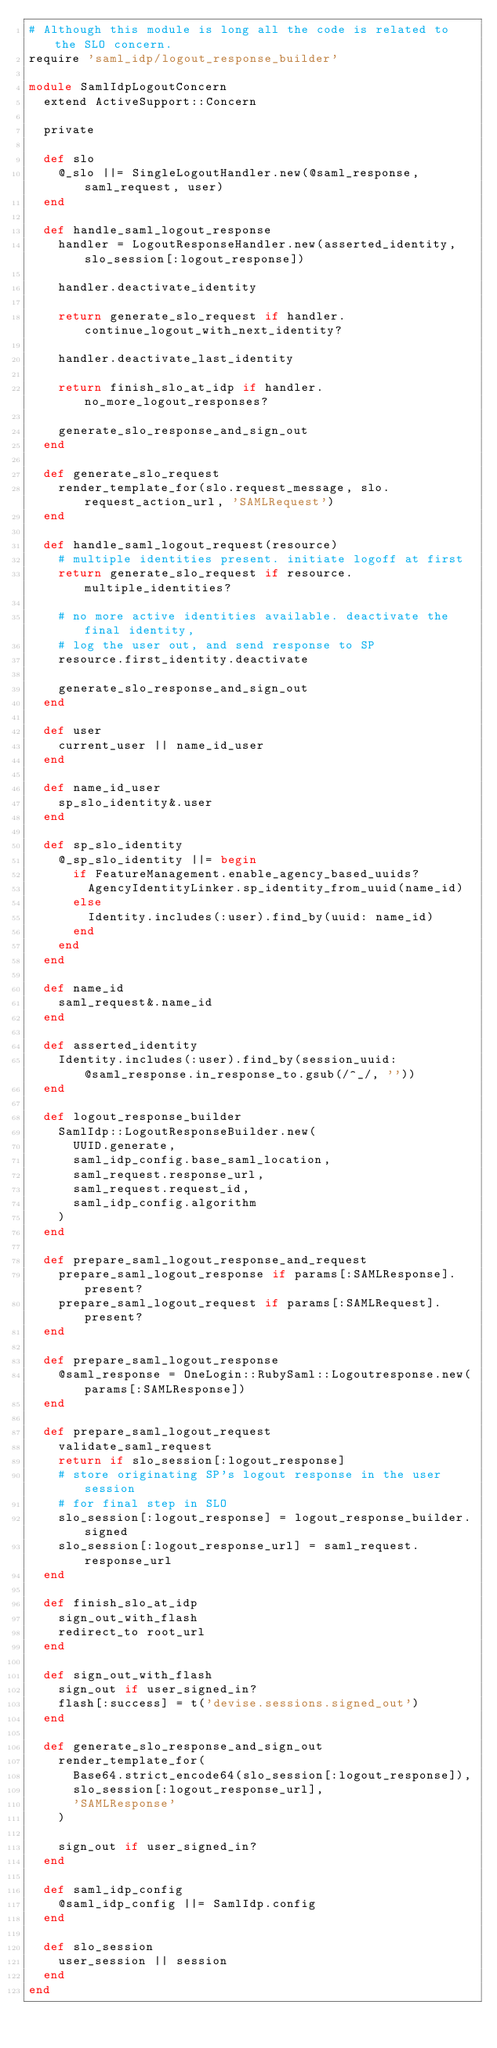<code> <loc_0><loc_0><loc_500><loc_500><_Ruby_># Although this module is long all the code is related to the SLO concern.
require 'saml_idp/logout_response_builder'

module SamlIdpLogoutConcern
  extend ActiveSupport::Concern

  private

  def slo
    @_slo ||= SingleLogoutHandler.new(@saml_response, saml_request, user)
  end

  def handle_saml_logout_response
    handler = LogoutResponseHandler.new(asserted_identity, slo_session[:logout_response])

    handler.deactivate_identity

    return generate_slo_request if handler.continue_logout_with_next_identity?

    handler.deactivate_last_identity

    return finish_slo_at_idp if handler.no_more_logout_responses?

    generate_slo_response_and_sign_out
  end

  def generate_slo_request
    render_template_for(slo.request_message, slo.request_action_url, 'SAMLRequest')
  end

  def handle_saml_logout_request(resource)
    # multiple identities present. initiate logoff at first
    return generate_slo_request if resource.multiple_identities?

    # no more active identities available. deactivate the final identity,
    # log the user out, and send response to SP
    resource.first_identity.deactivate

    generate_slo_response_and_sign_out
  end

  def user
    current_user || name_id_user
  end

  def name_id_user
    sp_slo_identity&.user
  end

  def sp_slo_identity
    @_sp_slo_identity ||= begin
      if FeatureManagement.enable_agency_based_uuids?
        AgencyIdentityLinker.sp_identity_from_uuid(name_id)
      else
        Identity.includes(:user).find_by(uuid: name_id)
      end
    end
  end

  def name_id
    saml_request&.name_id
  end

  def asserted_identity
    Identity.includes(:user).find_by(session_uuid: @saml_response.in_response_to.gsub(/^_/, ''))
  end

  def logout_response_builder
    SamlIdp::LogoutResponseBuilder.new(
      UUID.generate,
      saml_idp_config.base_saml_location,
      saml_request.response_url,
      saml_request.request_id,
      saml_idp_config.algorithm
    )
  end

  def prepare_saml_logout_response_and_request
    prepare_saml_logout_response if params[:SAMLResponse].present?
    prepare_saml_logout_request if params[:SAMLRequest].present?
  end

  def prepare_saml_logout_response
    @saml_response = OneLogin::RubySaml::Logoutresponse.new(params[:SAMLResponse])
  end

  def prepare_saml_logout_request
    validate_saml_request
    return if slo_session[:logout_response]
    # store originating SP's logout response in the user session
    # for final step in SLO
    slo_session[:logout_response] = logout_response_builder.signed
    slo_session[:logout_response_url] = saml_request.response_url
  end

  def finish_slo_at_idp
    sign_out_with_flash
    redirect_to root_url
  end

  def sign_out_with_flash
    sign_out if user_signed_in?
    flash[:success] = t('devise.sessions.signed_out')
  end

  def generate_slo_response_and_sign_out
    render_template_for(
      Base64.strict_encode64(slo_session[:logout_response]),
      slo_session[:logout_response_url],
      'SAMLResponse'
    )

    sign_out if user_signed_in?
  end

  def saml_idp_config
    @saml_idp_config ||= SamlIdp.config
  end

  def slo_session
    user_session || session
  end
end
</code> 